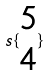Convert formula to latex. <formula><loc_0><loc_0><loc_500><loc_500>s \{ \begin{matrix} 5 \\ 4 \end{matrix} \}</formula> 